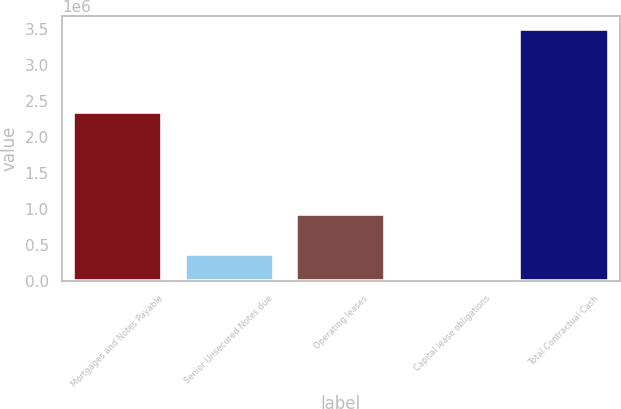Convert chart to OTSL. <chart><loc_0><loc_0><loc_500><loc_500><bar_chart><fcel>Mortgages and Notes Payable<fcel>Senior Unsecured Notes due<fcel>Operating leases<fcel>Capital lease obligations<fcel>Total Contractual Cash<nl><fcel>2.35317e+06<fcel>368974<fcel>928219<fcel>19907<fcel>3.51058e+06<nl></chart> 